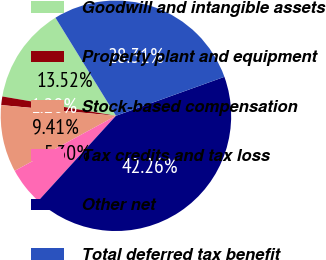Convert chart. <chart><loc_0><loc_0><loc_500><loc_500><pie_chart><fcel>Goodwill and intangible assets<fcel>Property plant and equipment<fcel>Stock-based compensation<fcel>Tax credits and tax loss<fcel>Other net<fcel>Total deferred tax benefit<nl><fcel>13.52%<fcel>1.2%<fcel>9.41%<fcel>5.3%<fcel>42.26%<fcel>28.31%<nl></chart> 